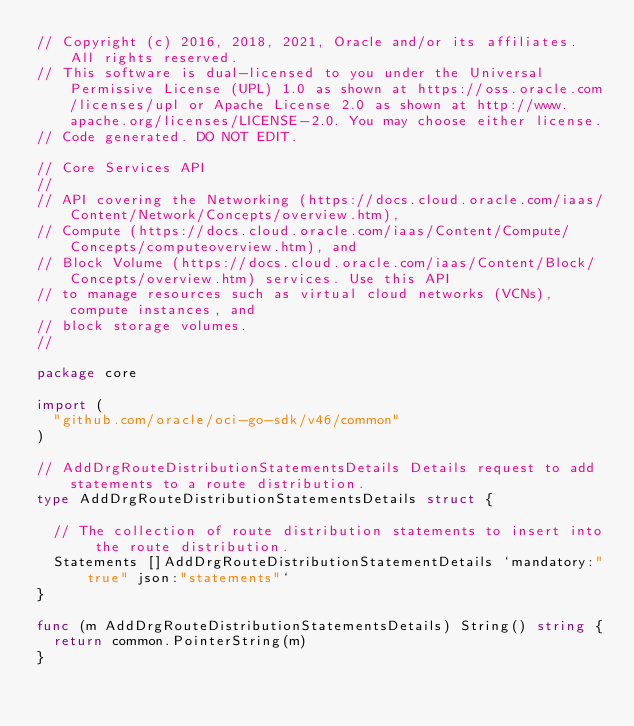Convert code to text. <code><loc_0><loc_0><loc_500><loc_500><_Go_>// Copyright (c) 2016, 2018, 2021, Oracle and/or its affiliates.  All rights reserved.
// This software is dual-licensed to you under the Universal Permissive License (UPL) 1.0 as shown at https://oss.oracle.com/licenses/upl or Apache License 2.0 as shown at http://www.apache.org/licenses/LICENSE-2.0. You may choose either license.
// Code generated. DO NOT EDIT.

// Core Services API
//
// API covering the Networking (https://docs.cloud.oracle.com/iaas/Content/Network/Concepts/overview.htm),
// Compute (https://docs.cloud.oracle.com/iaas/Content/Compute/Concepts/computeoverview.htm), and
// Block Volume (https://docs.cloud.oracle.com/iaas/Content/Block/Concepts/overview.htm) services. Use this API
// to manage resources such as virtual cloud networks (VCNs), compute instances, and
// block storage volumes.
//

package core

import (
	"github.com/oracle/oci-go-sdk/v46/common"
)

// AddDrgRouteDistributionStatementsDetails Details request to add statements to a route distribution.
type AddDrgRouteDistributionStatementsDetails struct {

	// The collection of route distribution statements to insert into the route distribution.
	Statements []AddDrgRouteDistributionStatementDetails `mandatory:"true" json:"statements"`
}

func (m AddDrgRouteDistributionStatementsDetails) String() string {
	return common.PointerString(m)
}
</code> 